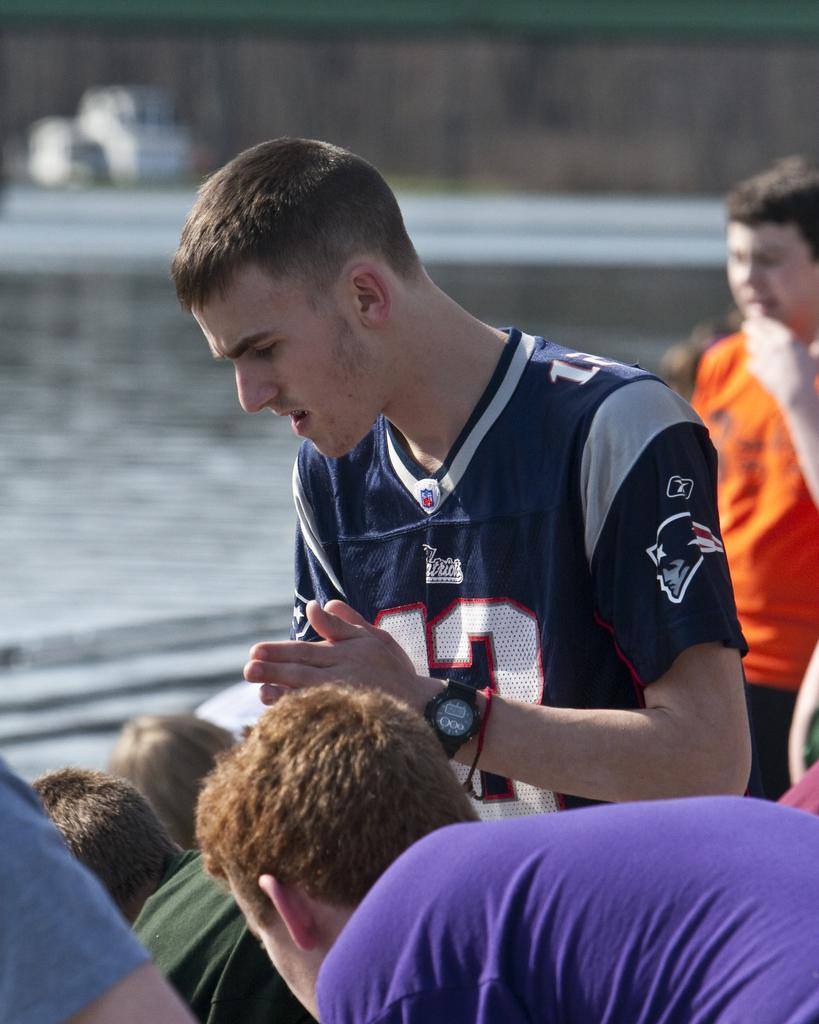<image>
Summarize the visual content of the image. people on a boat with one man wearing a number 12 patriots jersey 